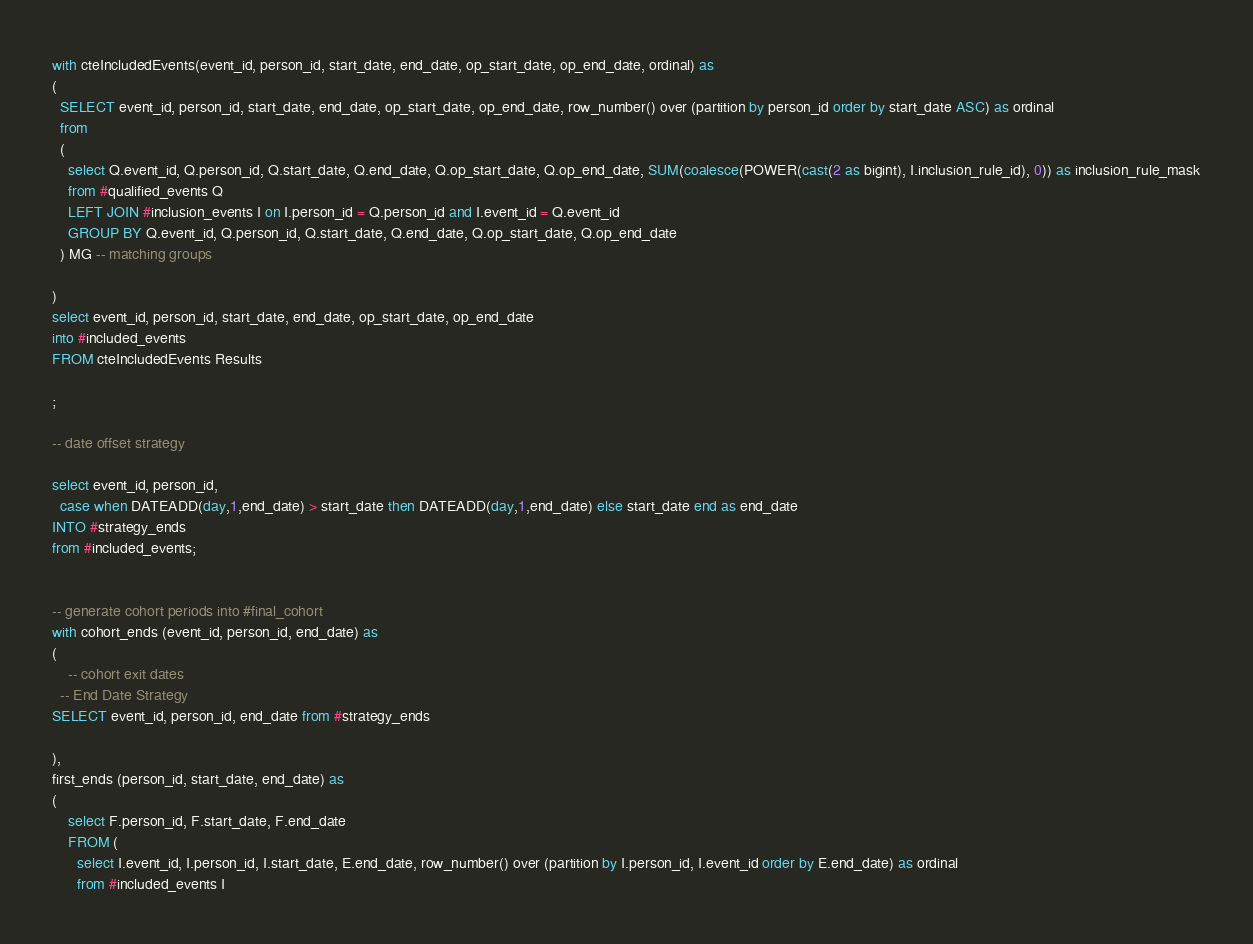<code> <loc_0><loc_0><loc_500><loc_500><_SQL_>
with cteIncludedEvents(event_id, person_id, start_date, end_date, op_start_date, op_end_date, ordinal) as
(
  SELECT event_id, person_id, start_date, end_date, op_start_date, op_end_date, row_number() over (partition by person_id order by start_date ASC) as ordinal
  from
  (
    select Q.event_id, Q.person_id, Q.start_date, Q.end_date, Q.op_start_date, Q.op_end_date, SUM(coalesce(POWER(cast(2 as bigint), I.inclusion_rule_id), 0)) as inclusion_rule_mask
    from #qualified_events Q
    LEFT JOIN #inclusion_events I on I.person_id = Q.person_id and I.event_id = Q.event_id
    GROUP BY Q.event_id, Q.person_id, Q.start_date, Q.end_date, Q.op_start_date, Q.op_end_date
  ) MG -- matching groups

)
select event_id, person_id, start_date, end_date, op_start_date, op_end_date
into #included_events
FROM cteIncludedEvents Results

;

-- date offset strategy

select event_id, person_id, 
  case when DATEADD(day,1,end_date) > start_date then DATEADD(day,1,end_date) else start_date end as end_date
INTO #strategy_ends
from #included_events;


-- generate cohort periods into #final_cohort
with cohort_ends (event_id, person_id, end_date) as
(
	-- cohort exit dates
  -- End Date Strategy
SELECT event_id, person_id, end_date from #strategy_ends

),
first_ends (person_id, start_date, end_date) as
(
	select F.person_id, F.start_date, F.end_date
	FROM (
	  select I.event_id, I.person_id, I.start_date, E.end_date, row_number() over (partition by I.person_id, I.event_id order by E.end_date) as ordinal 
	  from #included_events I</code> 